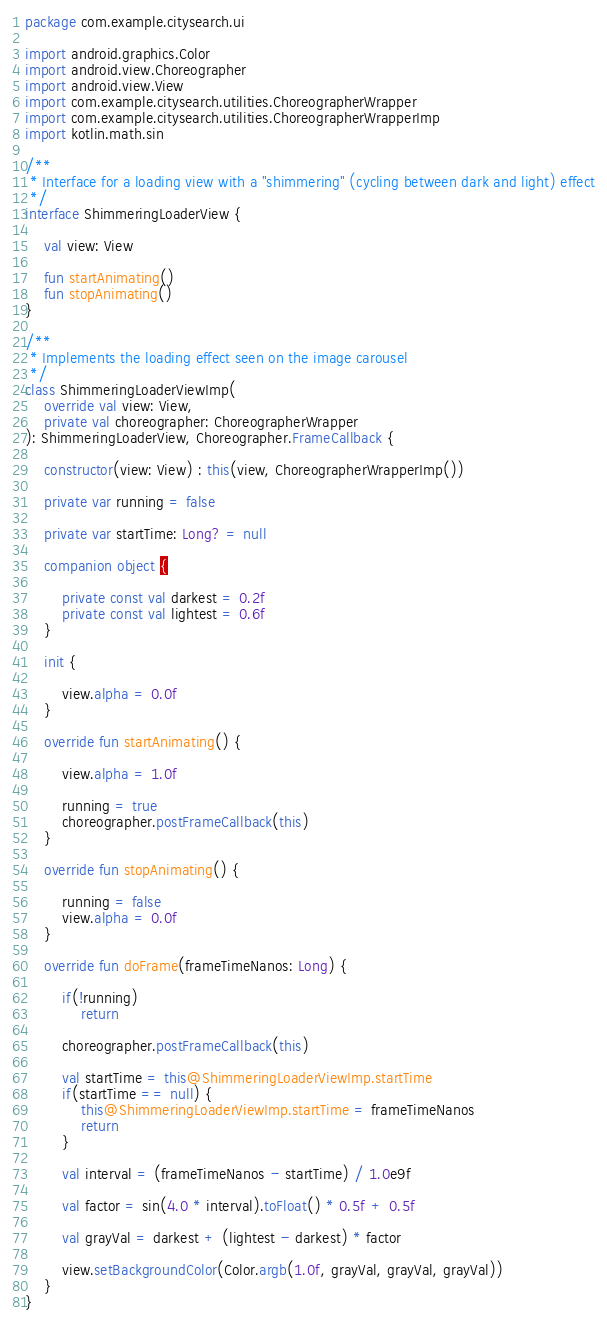<code> <loc_0><loc_0><loc_500><loc_500><_Kotlin_>package com.example.citysearch.ui

import android.graphics.Color
import android.view.Choreographer
import android.view.View
import com.example.citysearch.utilities.ChoreographerWrapper
import com.example.citysearch.utilities.ChoreographerWrapperImp
import kotlin.math.sin

/**
 * Interface for a loading view with a "shimmering" (cycling between dark and light) effect
 */
interface ShimmeringLoaderView {

    val view: View

    fun startAnimating()
    fun stopAnimating()
}

/**
 * Implements the loading effect seen on the image carousel
 */
class ShimmeringLoaderViewImp(
    override val view: View,
    private val choreographer: ChoreographerWrapper
): ShimmeringLoaderView, Choreographer.FrameCallback {

    constructor(view: View) : this(view, ChoreographerWrapperImp())

    private var running = false

    private var startTime: Long? = null

    companion object {

        private const val darkest = 0.2f
        private const val lightest = 0.6f
    }

    init {

        view.alpha = 0.0f
    }

    override fun startAnimating() {

        view.alpha = 1.0f

        running = true
        choreographer.postFrameCallback(this)
    }

    override fun stopAnimating() {

        running = false
        view.alpha = 0.0f
    }

    override fun doFrame(frameTimeNanos: Long) {

        if(!running)
            return

        choreographer.postFrameCallback(this)

        val startTime = this@ShimmeringLoaderViewImp.startTime
        if(startTime == null) {
            this@ShimmeringLoaderViewImp.startTime = frameTimeNanos
            return
        }

        val interval = (frameTimeNanos - startTime) / 1.0e9f

        val factor = sin(4.0 * interval).toFloat() * 0.5f + 0.5f

        val grayVal = darkest + (lightest - darkest) * factor

        view.setBackgroundColor(Color.argb(1.0f, grayVal, grayVal, grayVal))
    }
}</code> 